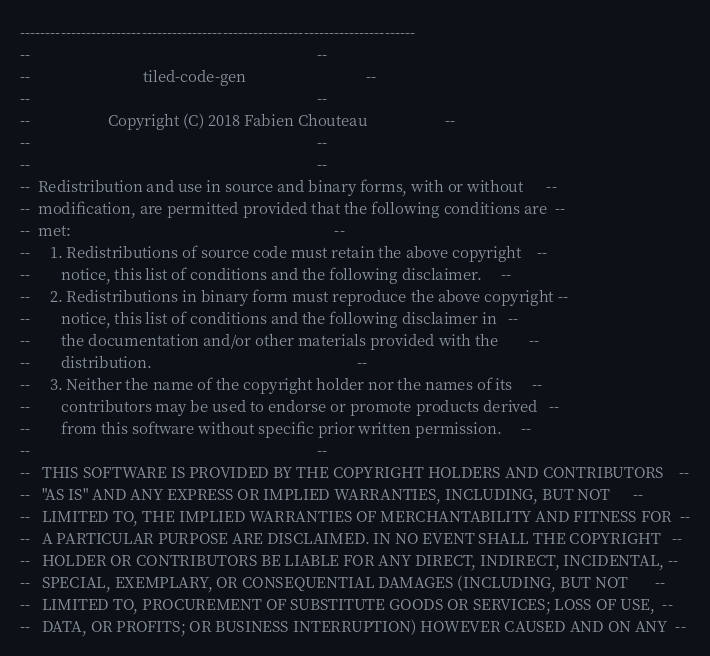Convert code to text. <code><loc_0><loc_0><loc_500><loc_500><_Ada_>------------------------------------------------------------------------------
--                                                                          --
--                             tiled-code-gen                               --
--                                                                          --
--                    Copyright (C) 2018 Fabien Chouteau                    --
--                                                                          --
--                                                                          --
--  Redistribution and use in source and binary forms, with or without      --
--  modification, are permitted provided that the following conditions are  --
--  met:                                                                    --
--     1. Redistributions of source code must retain the above copyright    --
--        notice, this list of conditions and the following disclaimer.     --
--     2. Redistributions in binary form must reproduce the above copyright --
--        notice, this list of conditions and the following disclaimer in   --
--        the documentation and/or other materials provided with the        --
--        distribution.                                                     --
--     3. Neither the name of the copyright holder nor the names of its     --
--        contributors may be used to endorse or promote products derived   --
--        from this software without specific prior written permission.     --
--                                                                          --
--   THIS SOFTWARE IS PROVIDED BY THE COPYRIGHT HOLDERS AND CONTRIBUTORS    --
--   "AS IS" AND ANY EXPRESS OR IMPLIED WARRANTIES, INCLUDING, BUT NOT      --
--   LIMITED TO, THE IMPLIED WARRANTIES OF MERCHANTABILITY AND FITNESS FOR  --
--   A PARTICULAR PURPOSE ARE DISCLAIMED. IN NO EVENT SHALL THE COPYRIGHT   --
--   HOLDER OR CONTRIBUTORS BE LIABLE FOR ANY DIRECT, INDIRECT, INCIDENTAL, --
--   SPECIAL, EXEMPLARY, OR CONSEQUENTIAL DAMAGES (INCLUDING, BUT NOT       --
--   LIMITED TO, PROCUREMENT OF SUBSTITUTE GOODS OR SERVICES; LOSS OF USE,  --
--   DATA, OR PROFITS; OR BUSINESS INTERRUPTION) HOWEVER CAUSED AND ON ANY  --</code> 